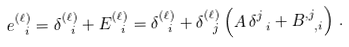Convert formula to latex. <formula><loc_0><loc_0><loc_500><loc_500>e ^ { ( \ell ) } _ { \ i } = \delta ^ { ( \ell ) } _ { \ i } + E ^ { ( \ell ) } _ { \ i } = \delta ^ { ( \ell ) } _ { \ i } + \delta ^ { ( \ell ) } _ { \ j } \left ( A \, \delta ^ { j } _ { \ i } + B ^ { , j } _ { \ , i } \right ) \, .</formula> 